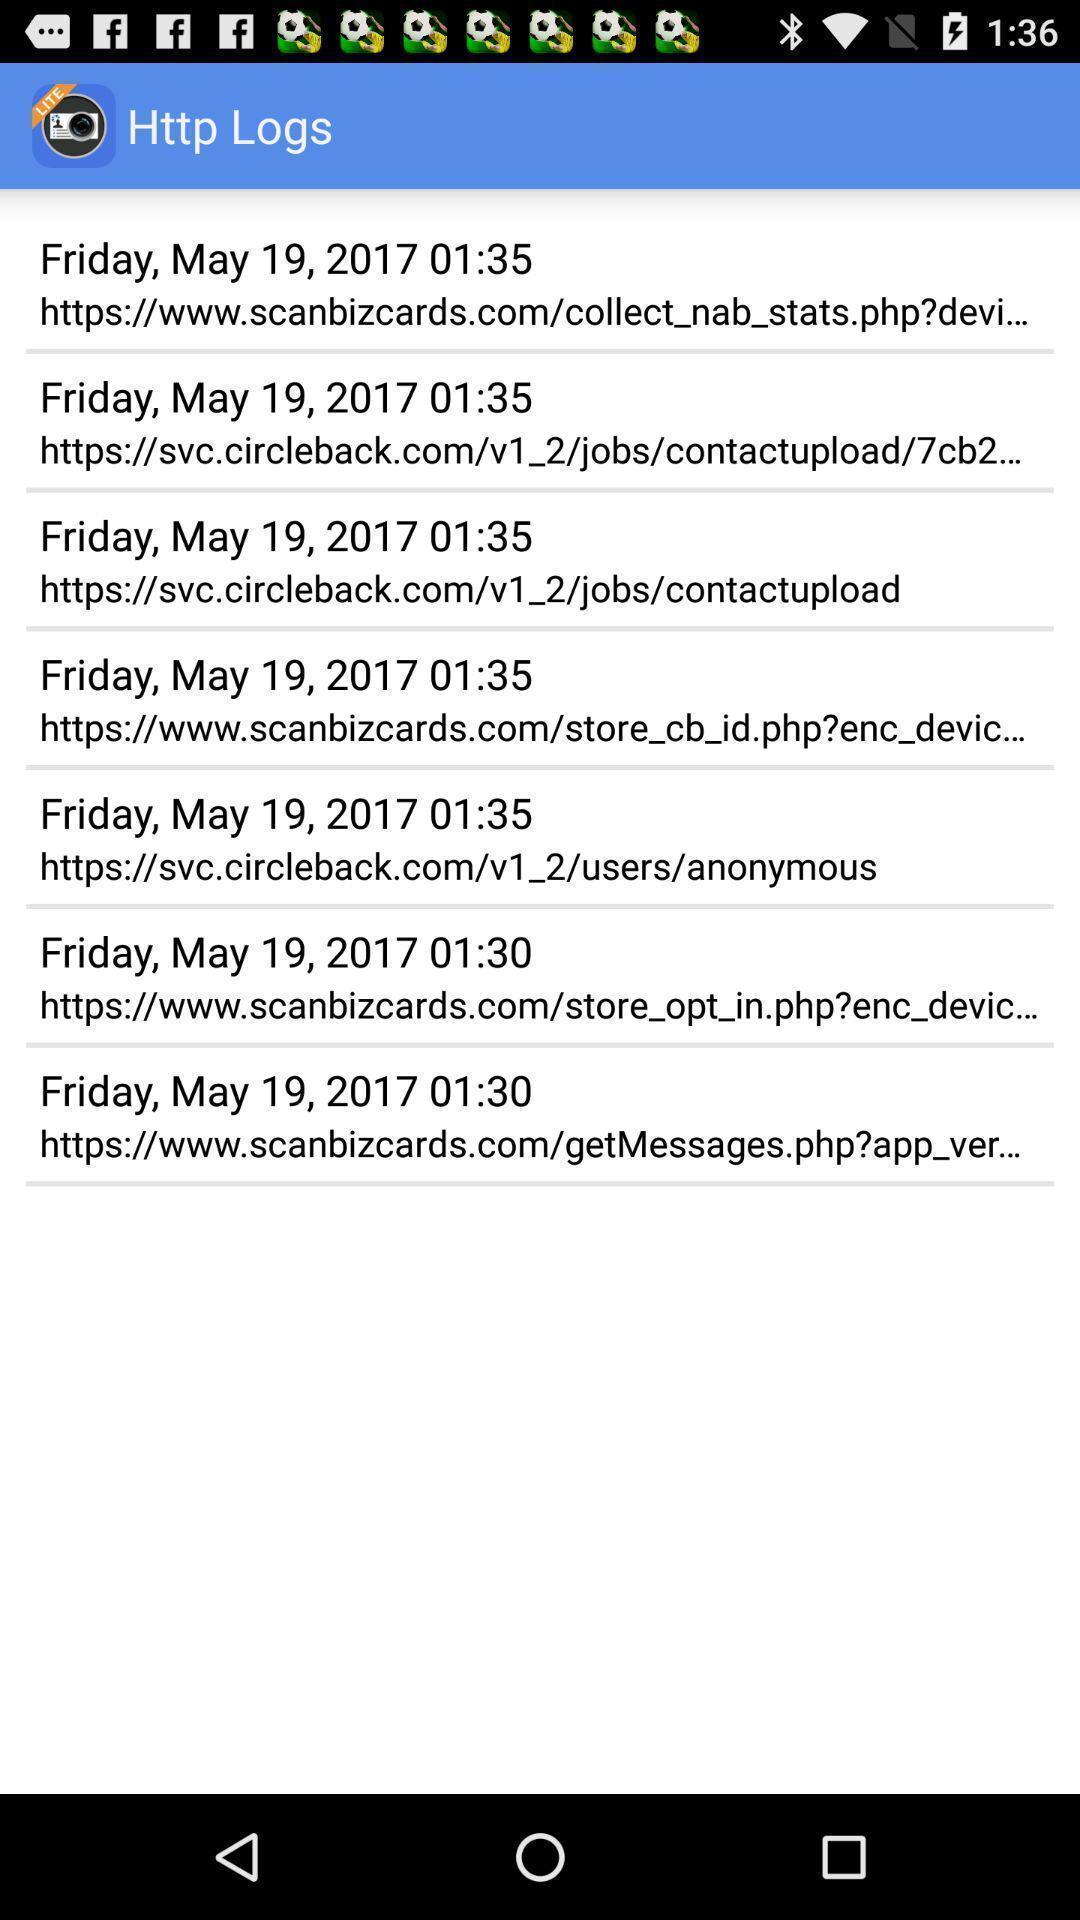What can you discern from this picture? Screen display logs page in business card app. 